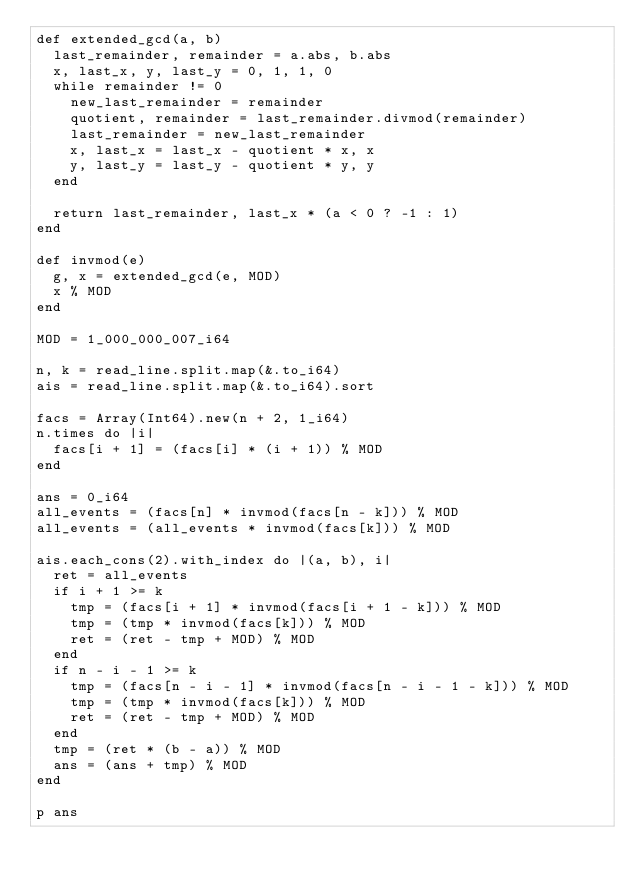<code> <loc_0><loc_0><loc_500><loc_500><_Crystal_>def extended_gcd(a, b)
  last_remainder, remainder = a.abs, b.abs
  x, last_x, y, last_y = 0, 1, 1, 0
  while remainder != 0
    new_last_remainder = remainder
    quotient, remainder = last_remainder.divmod(remainder)
    last_remainder = new_last_remainder
    x, last_x = last_x - quotient * x, x
    y, last_y = last_y - quotient * y, y
  end

  return last_remainder, last_x * (a < 0 ? -1 : 1)
end

def invmod(e)
  g, x = extended_gcd(e, MOD)
  x % MOD
end

MOD = 1_000_000_007_i64

n, k = read_line.split.map(&.to_i64)
ais = read_line.split.map(&.to_i64).sort

facs = Array(Int64).new(n + 2, 1_i64)
n.times do |i|
  facs[i + 1] = (facs[i] * (i + 1)) % MOD
end

ans = 0_i64
all_events = (facs[n] * invmod(facs[n - k])) % MOD
all_events = (all_events * invmod(facs[k])) % MOD

ais.each_cons(2).with_index do |(a, b), i|
  ret = all_events
  if i + 1 >= k
    tmp = (facs[i + 1] * invmod(facs[i + 1 - k])) % MOD
    tmp = (tmp * invmod(facs[k])) % MOD
    ret = (ret - tmp + MOD) % MOD
  end
  if n - i - 1 >= k
    tmp = (facs[n - i - 1] * invmod(facs[n - i - 1 - k])) % MOD
    tmp = (tmp * invmod(facs[k])) % MOD
    ret = (ret - tmp + MOD) % MOD
  end
  tmp = (ret * (b - a)) % MOD
  ans = (ans + tmp) % MOD
end

p ans

</code> 